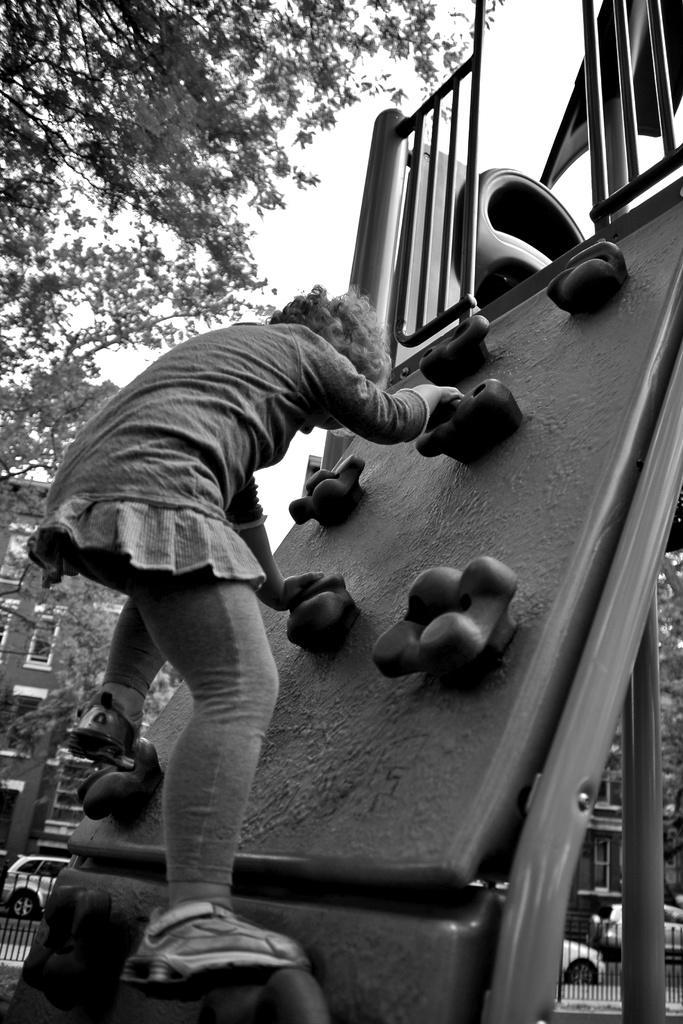In one or two sentences, can you explain what this image depicts? This is the black and white picture of a girl climbing a kids slide, in the back there are buildings and trees,vehicles going on the road. 